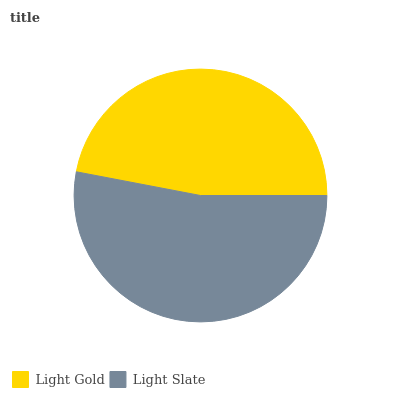Is Light Gold the minimum?
Answer yes or no. Yes. Is Light Slate the maximum?
Answer yes or no. Yes. Is Light Slate the minimum?
Answer yes or no. No. Is Light Slate greater than Light Gold?
Answer yes or no. Yes. Is Light Gold less than Light Slate?
Answer yes or no. Yes. Is Light Gold greater than Light Slate?
Answer yes or no. No. Is Light Slate less than Light Gold?
Answer yes or no. No. Is Light Slate the high median?
Answer yes or no. Yes. Is Light Gold the low median?
Answer yes or no. Yes. Is Light Gold the high median?
Answer yes or no. No. Is Light Slate the low median?
Answer yes or no. No. 